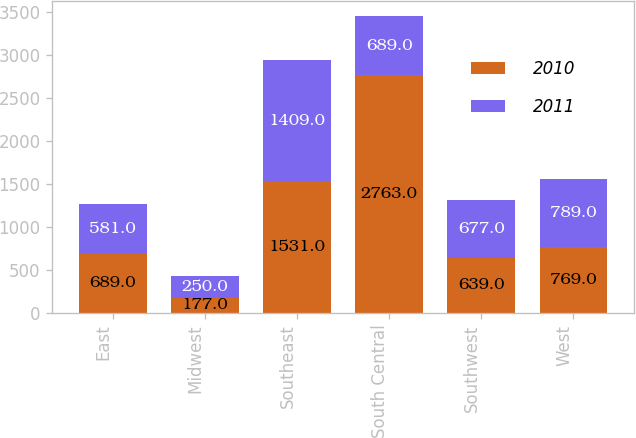<chart> <loc_0><loc_0><loc_500><loc_500><stacked_bar_chart><ecel><fcel>East<fcel>Midwest<fcel>Southeast<fcel>South Central<fcel>Southwest<fcel>West<nl><fcel>2010<fcel>689<fcel>177<fcel>1531<fcel>2763<fcel>639<fcel>769<nl><fcel>2011<fcel>581<fcel>250<fcel>1409<fcel>689<fcel>677<fcel>789<nl></chart> 